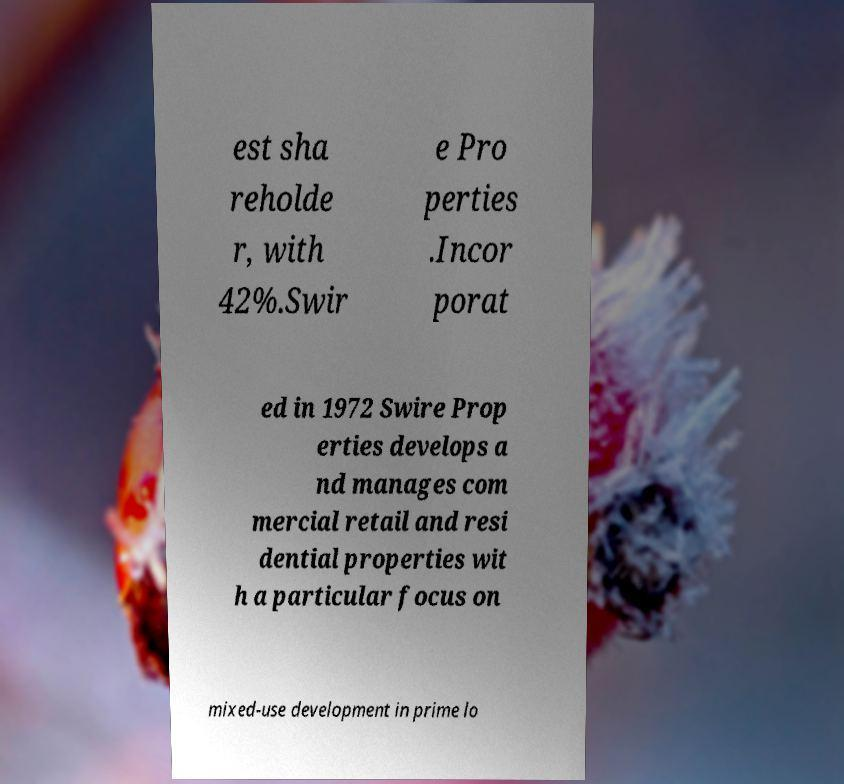What messages or text are displayed in this image? I need them in a readable, typed format. est sha reholde r, with 42%.Swir e Pro perties .Incor porat ed in 1972 Swire Prop erties develops a nd manages com mercial retail and resi dential properties wit h a particular focus on mixed-use development in prime lo 